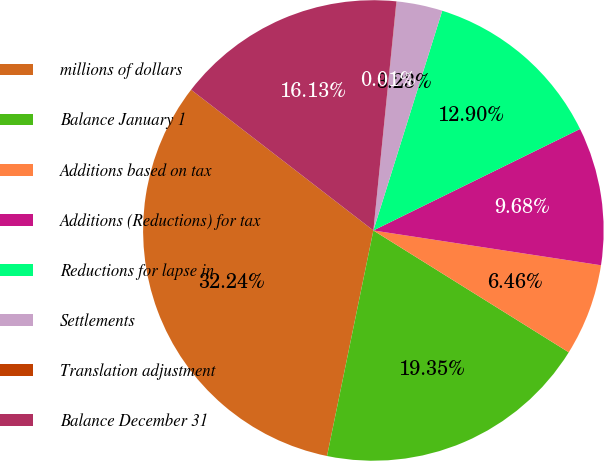<chart> <loc_0><loc_0><loc_500><loc_500><pie_chart><fcel>millions of dollars<fcel>Balance January 1<fcel>Additions based on tax<fcel>Additions (Reductions) for tax<fcel>Reductions for lapse in<fcel>Settlements<fcel>Translation adjustment<fcel>Balance December 31<nl><fcel>32.24%<fcel>19.35%<fcel>6.46%<fcel>9.68%<fcel>12.9%<fcel>3.23%<fcel>0.01%<fcel>16.13%<nl></chart> 